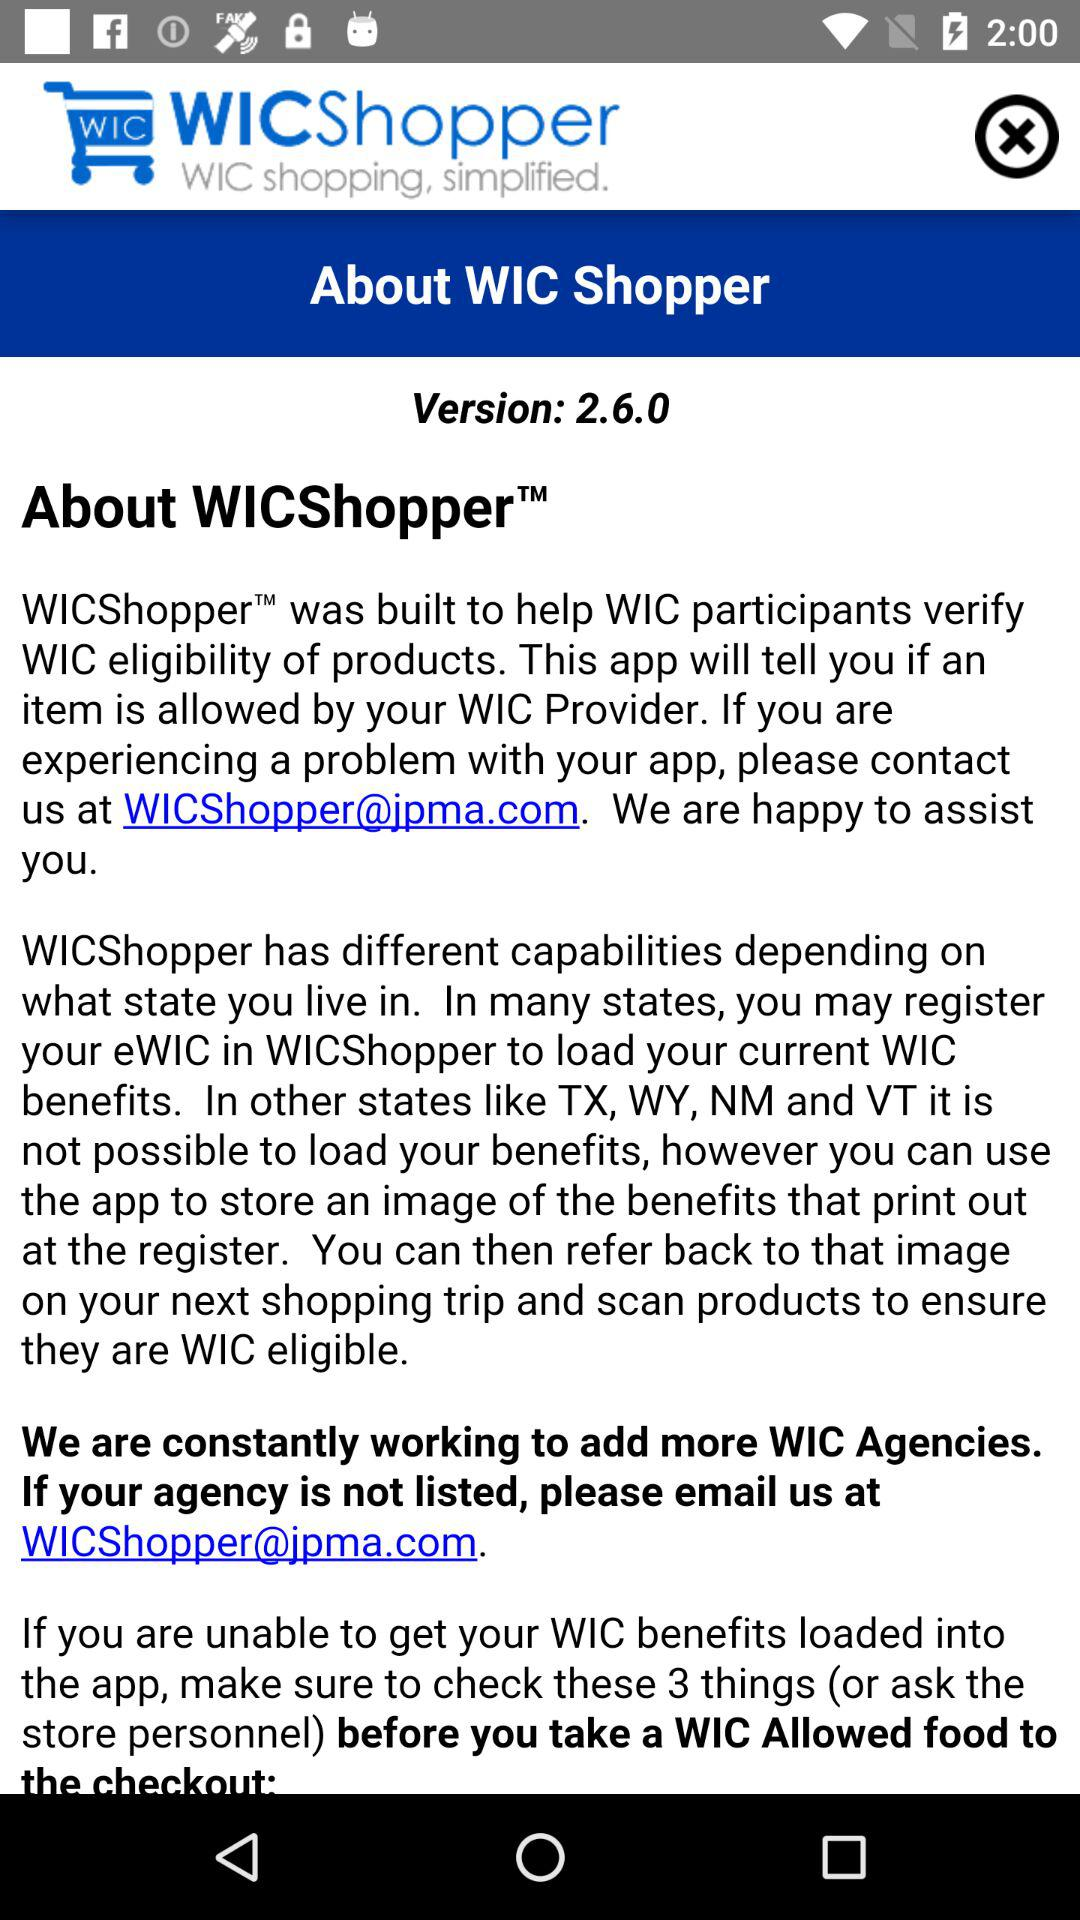What is the app name? The app name is "WICShopper". 